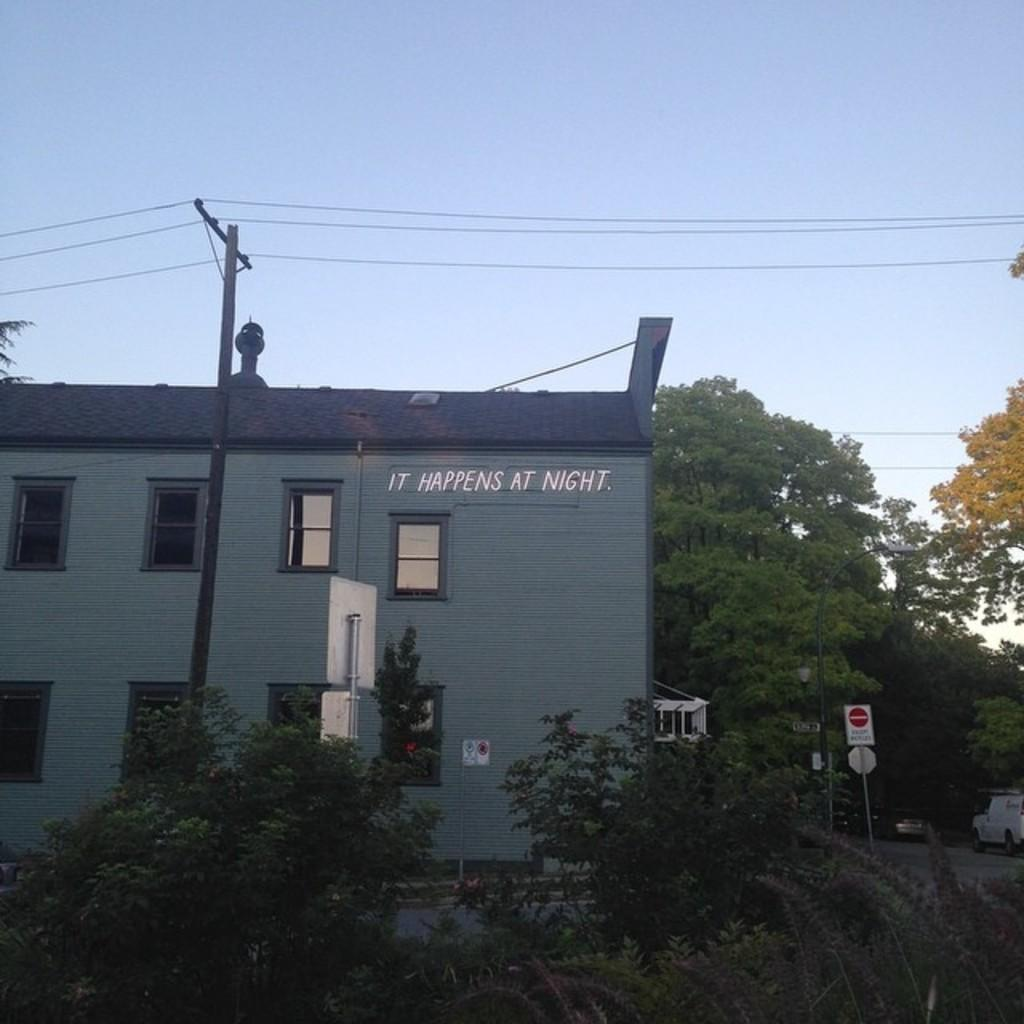What type of structure is in the image? There is a building in the image. What feature of the building is mentioned in the facts? The building has many windows. What can be seen around the building? Trees are present around the building. What is located on the left side of the image? There is an electric pole on the left side of the image. What is visible in the background of the image? The sky is visible in the image. What type of ship can be seen sailing in the sky in the image? There is no ship present in the image, and the sky is visible but does not contain any ships. What kind of yarn is being used to create the building in the image? The building is not made of yarn; it is a solid structure made of materials like brick, concrete, or wood. 